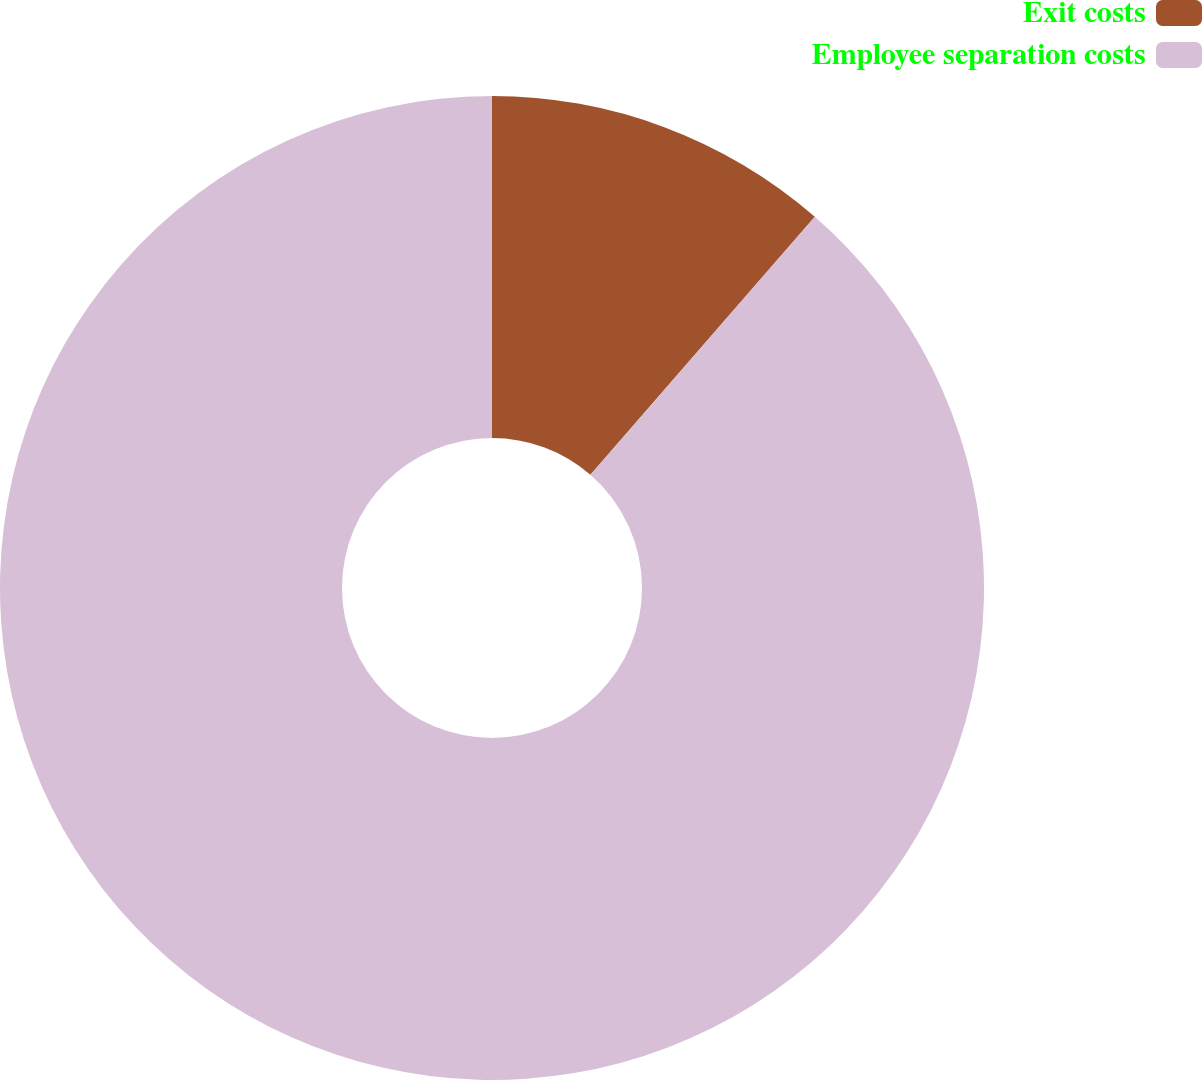Convert chart to OTSL. <chart><loc_0><loc_0><loc_500><loc_500><pie_chart><fcel>Exit costs<fcel>Employee separation costs<nl><fcel>11.39%<fcel>88.61%<nl></chart> 